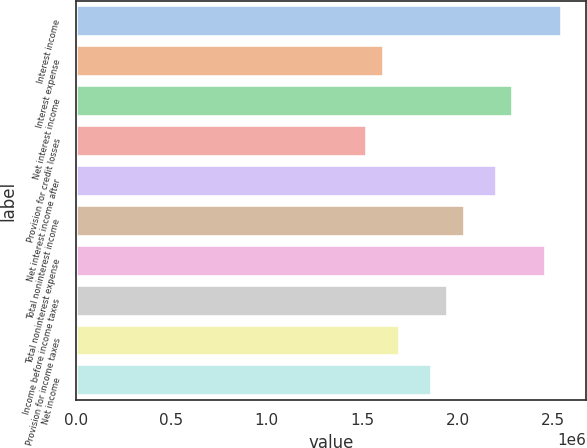<chart> <loc_0><loc_0><loc_500><loc_500><bar_chart><fcel>Interest income<fcel>Interest expense<fcel>Net interest income<fcel>Provision for credit losses<fcel>Net interest income after<fcel>Total noninterest income<fcel>Total noninterest expense<fcel>Income before income taxes<fcel>Provision for income taxes<fcel>Net income<nl><fcel>2.54612e+06<fcel>1.61255e+06<fcel>2.29151e+06<fcel>1.52767e+06<fcel>2.20664e+06<fcel>2.0369e+06<fcel>2.46125e+06<fcel>1.95203e+06<fcel>1.69742e+06<fcel>1.86716e+06<nl></chart> 